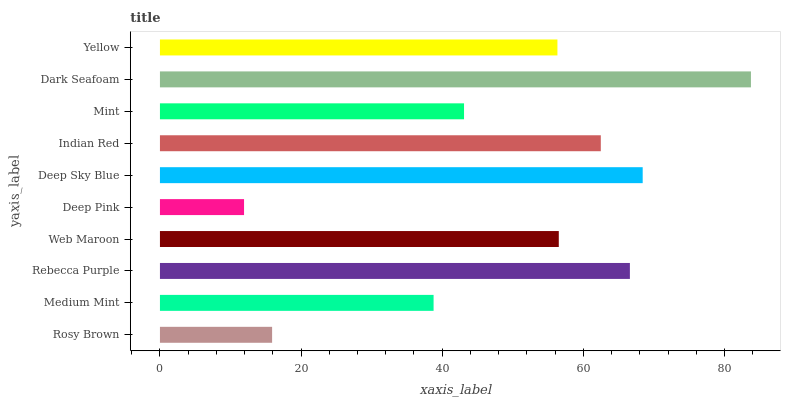Is Deep Pink the minimum?
Answer yes or no. Yes. Is Dark Seafoam the maximum?
Answer yes or no. Yes. Is Medium Mint the minimum?
Answer yes or no. No. Is Medium Mint the maximum?
Answer yes or no. No. Is Medium Mint greater than Rosy Brown?
Answer yes or no. Yes. Is Rosy Brown less than Medium Mint?
Answer yes or no. Yes. Is Rosy Brown greater than Medium Mint?
Answer yes or no. No. Is Medium Mint less than Rosy Brown?
Answer yes or no. No. Is Web Maroon the high median?
Answer yes or no. Yes. Is Yellow the low median?
Answer yes or no. Yes. Is Rebecca Purple the high median?
Answer yes or no. No. Is Rosy Brown the low median?
Answer yes or no. No. 